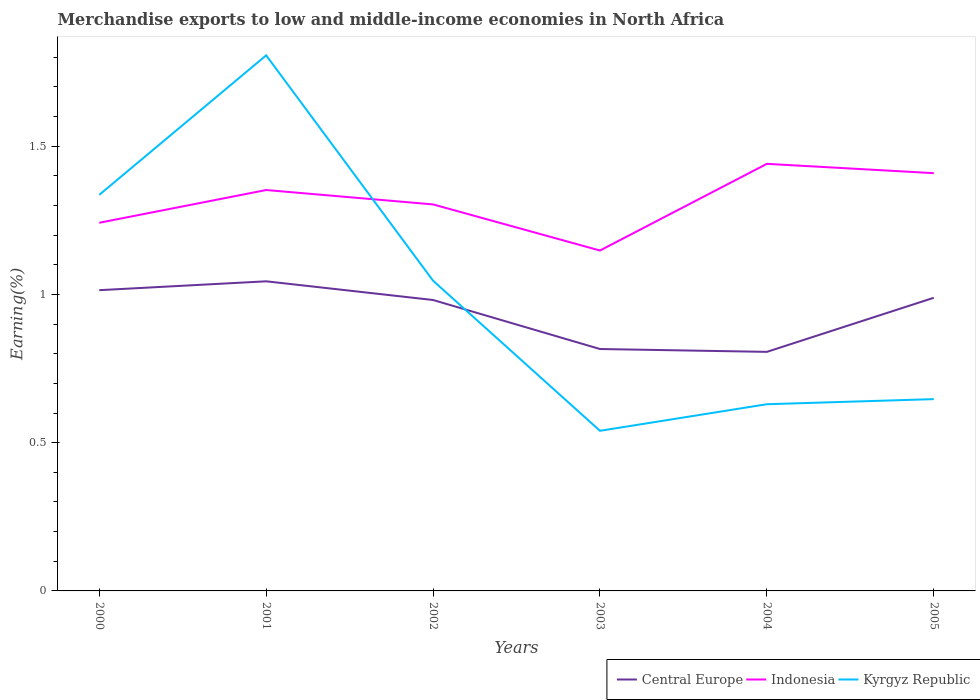How many different coloured lines are there?
Make the answer very short. 3. Does the line corresponding to Central Europe intersect with the line corresponding to Indonesia?
Your answer should be compact. No. Is the number of lines equal to the number of legend labels?
Provide a short and direct response. Yes. Across all years, what is the maximum percentage of amount earned from merchandise exports in Central Europe?
Give a very brief answer. 0.81. What is the total percentage of amount earned from merchandise exports in Indonesia in the graph?
Keep it short and to the point. -0.11. What is the difference between the highest and the second highest percentage of amount earned from merchandise exports in Indonesia?
Provide a short and direct response. 0.29. How many years are there in the graph?
Give a very brief answer. 6. What is the difference between two consecutive major ticks on the Y-axis?
Your answer should be very brief. 0.5. Are the values on the major ticks of Y-axis written in scientific E-notation?
Provide a succinct answer. No. Does the graph contain any zero values?
Provide a short and direct response. No. How many legend labels are there?
Your answer should be compact. 3. How are the legend labels stacked?
Give a very brief answer. Horizontal. What is the title of the graph?
Offer a terse response. Merchandise exports to low and middle-income economies in North Africa. What is the label or title of the Y-axis?
Offer a terse response. Earning(%). What is the Earning(%) of Central Europe in 2000?
Offer a very short reply. 1.01. What is the Earning(%) in Indonesia in 2000?
Ensure brevity in your answer.  1.24. What is the Earning(%) in Kyrgyz Republic in 2000?
Give a very brief answer. 1.34. What is the Earning(%) of Central Europe in 2001?
Offer a terse response. 1.04. What is the Earning(%) of Indonesia in 2001?
Give a very brief answer. 1.35. What is the Earning(%) of Kyrgyz Republic in 2001?
Your answer should be compact. 1.81. What is the Earning(%) in Central Europe in 2002?
Your response must be concise. 0.98. What is the Earning(%) of Indonesia in 2002?
Offer a terse response. 1.3. What is the Earning(%) of Kyrgyz Republic in 2002?
Provide a short and direct response. 1.05. What is the Earning(%) of Central Europe in 2003?
Keep it short and to the point. 0.82. What is the Earning(%) in Indonesia in 2003?
Your response must be concise. 1.15. What is the Earning(%) of Kyrgyz Republic in 2003?
Your answer should be very brief. 0.54. What is the Earning(%) of Central Europe in 2004?
Your answer should be very brief. 0.81. What is the Earning(%) in Indonesia in 2004?
Offer a terse response. 1.44. What is the Earning(%) in Kyrgyz Republic in 2004?
Offer a terse response. 0.63. What is the Earning(%) of Central Europe in 2005?
Provide a succinct answer. 0.99. What is the Earning(%) of Indonesia in 2005?
Give a very brief answer. 1.41. What is the Earning(%) of Kyrgyz Republic in 2005?
Offer a terse response. 0.65. Across all years, what is the maximum Earning(%) in Central Europe?
Provide a short and direct response. 1.04. Across all years, what is the maximum Earning(%) in Indonesia?
Make the answer very short. 1.44. Across all years, what is the maximum Earning(%) of Kyrgyz Republic?
Your answer should be very brief. 1.81. Across all years, what is the minimum Earning(%) of Central Europe?
Give a very brief answer. 0.81. Across all years, what is the minimum Earning(%) of Indonesia?
Offer a terse response. 1.15. Across all years, what is the minimum Earning(%) in Kyrgyz Republic?
Offer a terse response. 0.54. What is the total Earning(%) in Central Europe in the graph?
Offer a very short reply. 5.65. What is the total Earning(%) of Indonesia in the graph?
Keep it short and to the point. 7.9. What is the total Earning(%) in Kyrgyz Republic in the graph?
Provide a succinct answer. 6.01. What is the difference between the Earning(%) in Central Europe in 2000 and that in 2001?
Give a very brief answer. -0.03. What is the difference between the Earning(%) in Indonesia in 2000 and that in 2001?
Your answer should be very brief. -0.11. What is the difference between the Earning(%) in Kyrgyz Republic in 2000 and that in 2001?
Keep it short and to the point. -0.47. What is the difference between the Earning(%) of Central Europe in 2000 and that in 2002?
Ensure brevity in your answer.  0.03. What is the difference between the Earning(%) in Indonesia in 2000 and that in 2002?
Give a very brief answer. -0.06. What is the difference between the Earning(%) of Kyrgyz Republic in 2000 and that in 2002?
Make the answer very short. 0.29. What is the difference between the Earning(%) in Central Europe in 2000 and that in 2003?
Provide a succinct answer. 0.2. What is the difference between the Earning(%) of Indonesia in 2000 and that in 2003?
Provide a succinct answer. 0.09. What is the difference between the Earning(%) in Kyrgyz Republic in 2000 and that in 2003?
Provide a succinct answer. 0.8. What is the difference between the Earning(%) in Central Europe in 2000 and that in 2004?
Make the answer very short. 0.21. What is the difference between the Earning(%) in Indonesia in 2000 and that in 2004?
Your answer should be compact. -0.2. What is the difference between the Earning(%) of Kyrgyz Republic in 2000 and that in 2004?
Ensure brevity in your answer.  0.71. What is the difference between the Earning(%) in Central Europe in 2000 and that in 2005?
Offer a very short reply. 0.03. What is the difference between the Earning(%) in Indonesia in 2000 and that in 2005?
Give a very brief answer. -0.17. What is the difference between the Earning(%) of Kyrgyz Republic in 2000 and that in 2005?
Make the answer very short. 0.69. What is the difference between the Earning(%) of Central Europe in 2001 and that in 2002?
Your answer should be compact. 0.06. What is the difference between the Earning(%) of Indonesia in 2001 and that in 2002?
Keep it short and to the point. 0.05. What is the difference between the Earning(%) in Kyrgyz Republic in 2001 and that in 2002?
Your answer should be compact. 0.76. What is the difference between the Earning(%) of Central Europe in 2001 and that in 2003?
Provide a short and direct response. 0.23. What is the difference between the Earning(%) in Indonesia in 2001 and that in 2003?
Your answer should be very brief. 0.2. What is the difference between the Earning(%) in Kyrgyz Republic in 2001 and that in 2003?
Your answer should be very brief. 1.27. What is the difference between the Earning(%) in Central Europe in 2001 and that in 2004?
Make the answer very short. 0.24. What is the difference between the Earning(%) of Indonesia in 2001 and that in 2004?
Provide a short and direct response. -0.09. What is the difference between the Earning(%) of Kyrgyz Republic in 2001 and that in 2004?
Give a very brief answer. 1.18. What is the difference between the Earning(%) of Central Europe in 2001 and that in 2005?
Offer a very short reply. 0.06. What is the difference between the Earning(%) in Indonesia in 2001 and that in 2005?
Provide a short and direct response. -0.06. What is the difference between the Earning(%) in Kyrgyz Republic in 2001 and that in 2005?
Provide a succinct answer. 1.16. What is the difference between the Earning(%) of Central Europe in 2002 and that in 2003?
Offer a terse response. 0.17. What is the difference between the Earning(%) of Indonesia in 2002 and that in 2003?
Your answer should be very brief. 0.16. What is the difference between the Earning(%) in Kyrgyz Republic in 2002 and that in 2003?
Your answer should be compact. 0.51. What is the difference between the Earning(%) in Central Europe in 2002 and that in 2004?
Offer a terse response. 0.17. What is the difference between the Earning(%) of Indonesia in 2002 and that in 2004?
Your response must be concise. -0.14. What is the difference between the Earning(%) in Kyrgyz Republic in 2002 and that in 2004?
Provide a succinct answer. 0.42. What is the difference between the Earning(%) of Central Europe in 2002 and that in 2005?
Ensure brevity in your answer.  -0.01. What is the difference between the Earning(%) of Indonesia in 2002 and that in 2005?
Ensure brevity in your answer.  -0.11. What is the difference between the Earning(%) of Kyrgyz Republic in 2002 and that in 2005?
Offer a terse response. 0.4. What is the difference between the Earning(%) in Central Europe in 2003 and that in 2004?
Your answer should be compact. 0.01. What is the difference between the Earning(%) of Indonesia in 2003 and that in 2004?
Keep it short and to the point. -0.29. What is the difference between the Earning(%) in Kyrgyz Republic in 2003 and that in 2004?
Provide a short and direct response. -0.09. What is the difference between the Earning(%) of Central Europe in 2003 and that in 2005?
Offer a very short reply. -0.17. What is the difference between the Earning(%) in Indonesia in 2003 and that in 2005?
Make the answer very short. -0.26. What is the difference between the Earning(%) of Kyrgyz Republic in 2003 and that in 2005?
Offer a terse response. -0.11. What is the difference between the Earning(%) in Central Europe in 2004 and that in 2005?
Your response must be concise. -0.18. What is the difference between the Earning(%) in Indonesia in 2004 and that in 2005?
Make the answer very short. 0.03. What is the difference between the Earning(%) in Kyrgyz Republic in 2004 and that in 2005?
Offer a terse response. -0.02. What is the difference between the Earning(%) of Central Europe in 2000 and the Earning(%) of Indonesia in 2001?
Ensure brevity in your answer.  -0.34. What is the difference between the Earning(%) of Central Europe in 2000 and the Earning(%) of Kyrgyz Republic in 2001?
Offer a very short reply. -0.79. What is the difference between the Earning(%) in Indonesia in 2000 and the Earning(%) in Kyrgyz Republic in 2001?
Offer a terse response. -0.56. What is the difference between the Earning(%) of Central Europe in 2000 and the Earning(%) of Indonesia in 2002?
Give a very brief answer. -0.29. What is the difference between the Earning(%) in Central Europe in 2000 and the Earning(%) in Kyrgyz Republic in 2002?
Provide a succinct answer. -0.03. What is the difference between the Earning(%) of Indonesia in 2000 and the Earning(%) of Kyrgyz Republic in 2002?
Provide a short and direct response. 0.2. What is the difference between the Earning(%) in Central Europe in 2000 and the Earning(%) in Indonesia in 2003?
Give a very brief answer. -0.13. What is the difference between the Earning(%) in Central Europe in 2000 and the Earning(%) in Kyrgyz Republic in 2003?
Give a very brief answer. 0.47. What is the difference between the Earning(%) of Indonesia in 2000 and the Earning(%) of Kyrgyz Republic in 2003?
Your response must be concise. 0.7. What is the difference between the Earning(%) in Central Europe in 2000 and the Earning(%) in Indonesia in 2004?
Offer a terse response. -0.43. What is the difference between the Earning(%) of Central Europe in 2000 and the Earning(%) of Kyrgyz Republic in 2004?
Offer a terse response. 0.38. What is the difference between the Earning(%) in Indonesia in 2000 and the Earning(%) in Kyrgyz Republic in 2004?
Ensure brevity in your answer.  0.61. What is the difference between the Earning(%) in Central Europe in 2000 and the Earning(%) in Indonesia in 2005?
Provide a short and direct response. -0.39. What is the difference between the Earning(%) in Central Europe in 2000 and the Earning(%) in Kyrgyz Republic in 2005?
Your response must be concise. 0.37. What is the difference between the Earning(%) of Indonesia in 2000 and the Earning(%) of Kyrgyz Republic in 2005?
Your response must be concise. 0.59. What is the difference between the Earning(%) in Central Europe in 2001 and the Earning(%) in Indonesia in 2002?
Provide a succinct answer. -0.26. What is the difference between the Earning(%) of Central Europe in 2001 and the Earning(%) of Kyrgyz Republic in 2002?
Your answer should be very brief. -0. What is the difference between the Earning(%) in Indonesia in 2001 and the Earning(%) in Kyrgyz Republic in 2002?
Make the answer very short. 0.31. What is the difference between the Earning(%) of Central Europe in 2001 and the Earning(%) of Indonesia in 2003?
Your answer should be very brief. -0.1. What is the difference between the Earning(%) of Central Europe in 2001 and the Earning(%) of Kyrgyz Republic in 2003?
Keep it short and to the point. 0.5. What is the difference between the Earning(%) of Indonesia in 2001 and the Earning(%) of Kyrgyz Republic in 2003?
Your answer should be compact. 0.81. What is the difference between the Earning(%) of Central Europe in 2001 and the Earning(%) of Indonesia in 2004?
Offer a very short reply. -0.4. What is the difference between the Earning(%) in Central Europe in 2001 and the Earning(%) in Kyrgyz Republic in 2004?
Keep it short and to the point. 0.41. What is the difference between the Earning(%) of Indonesia in 2001 and the Earning(%) of Kyrgyz Republic in 2004?
Your response must be concise. 0.72. What is the difference between the Earning(%) in Central Europe in 2001 and the Earning(%) in Indonesia in 2005?
Make the answer very short. -0.36. What is the difference between the Earning(%) of Central Europe in 2001 and the Earning(%) of Kyrgyz Republic in 2005?
Provide a succinct answer. 0.4. What is the difference between the Earning(%) of Indonesia in 2001 and the Earning(%) of Kyrgyz Republic in 2005?
Ensure brevity in your answer.  0.71. What is the difference between the Earning(%) of Central Europe in 2002 and the Earning(%) of Indonesia in 2003?
Make the answer very short. -0.17. What is the difference between the Earning(%) in Central Europe in 2002 and the Earning(%) in Kyrgyz Republic in 2003?
Offer a terse response. 0.44. What is the difference between the Earning(%) of Indonesia in 2002 and the Earning(%) of Kyrgyz Republic in 2003?
Make the answer very short. 0.76. What is the difference between the Earning(%) in Central Europe in 2002 and the Earning(%) in Indonesia in 2004?
Your response must be concise. -0.46. What is the difference between the Earning(%) of Central Europe in 2002 and the Earning(%) of Kyrgyz Republic in 2004?
Provide a short and direct response. 0.35. What is the difference between the Earning(%) of Indonesia in 2002 and the Earning(%) of Kyrgyz Republic in 2004?
Make the answer very short. 0.67. What is the difference between the Earning(%) of Central Europe in 2002 and the Earning(%) of Indonesia in 2005?
Keep it short and to the point. -0.43. What is the difference between the Earning(%) in Central Europe in 2002 and the Earning(%) in Kyrgyz Republic in 2005?
Provide a short and direct response. 0.33. What is the difference between the Earning(%) of Indonesia in 2002 and the Earning(%) of Kyrgyz Republic in 2005?
Make the answer very short. 0.66. What is the difference between the Earning(%) in Central Europe in 2003 and the Earning(%) in Indonesia in 2004?
Offer a very short reply. -0.62. What is the difference between the Earning(%) in Central Europe in 2003 and the Earning(%) in Kyrgyz Republic in 2004?
Offer a terse response. 0.19. What is the difference between the Earning(%) of Indonesia in 2003 and the Earning(%) of Kyrgyz Republic in 2004?
Your response must be concise. 0.52. What is the difference between the Earning(%) in Central Europe in 2003 and the Earning(%) in Indonesia in 2005?
Offer a terse response. -0.59. What is the difference between the Earning(%) of Central Europe in 2003 and the Earning(%) of Kyrgyz Republic in 2005?
Offer a very short reply. 0.17. What is the difference between the Earning(%) in Indonesia in 2003 and the Earning(%) in Kyrgyz Republic in 2005?
Your answer should be very brief. 0.5. What is the difference between the Earning(%) in Central Europe in 2004 and the Earning(%) in Indonesia in 2005?
Make the answer very short. -0.6. What is the difference between the Earning(%) in Central Europe in 2004 and the Earning(%) in Kyrgyz Republic in 2005?
Provide a succinct answer. 0.16. What is the difference between the Earning(%) in Indonesia in 2004 and the Earning(%) in Kyrgyz Republic in 2005?
Offer a very short reply. 0.79. What is the average Earning(%) in Central Europe per year?
Offer a terse response. 0.94. What is the average Earning(%) in Indonesia per year?
Your response must be concise. 1.32. What is the average Earning(%) of Kyrgyz Republic per year?
Keep it short and to the point. 1. In the year 2000, what is the difference between the Earning(%) in Central Europe and Earning(%) in Indonesia?
Make the answer very short. -0.23. In the year 2000, what is the difference between the Earning(%) of Central Europe and Earning(%) of Kyrgyz Republic?
Keep it short and to the point. -0.32. In the year 2000, what is the difference between the Earning(%) of Indonesia and Earning(%) of Kyrgyz Republic?
Your response must be concise. -0.09. In the year 2001, what is the difference between the Earning(%) of Central Europe and Earning(%) of Indonesia?
Offer a terse response. -0.31. In the year 2001, what is the difference between the Earning(%) in Central Europe and Earning(%) in Kyrgyz Republic?
Provide a succinct answer. -0.76. In the year 2001, what is the difference between the Earning(%) of Indonesia and Earning(%) of Kyrgyz Republic?
Keep it short and to the point. -0.45. In the year 2002, what is the difference between the Earning(%) in Central Europe and Earning(%) in Indonesia?
Your answer should be compact. -0.32. In the year 2002, what is the difference between the Earning(%) in Central Europe and Earning(%) in Kyrgyz Republic?
Keep it short and to the point. -0.07. In the year 2002, what is the difference between the Earning(%) of Indonesia and Earning(%) of Kyrgyz Republic?
Ensure brevity in your answer.  0.26. In the year 2003, what is the difference between the Earning(%) in Central Europe and Earning(%) in Indonesia?
Offer a very short reply. -0.33. In the year 2003, what is the difference between the Earning(%) of Central Europe and Earning(%) of Kyrgyz Republic?
Your answer should be very brief. 0.28. In the year 2003, what is the difference between the Earning(%) of Indonesia and Earning(%) of Kyrgyz Republic?
Offer a terse response. 0.61. In the year 2004, what is the difference between the Earning(%) in Central Europe and Earning(%) in Indonesia?
Offer a terse response. -0.63. In the year 2004, what is the difference between the Earning(%) in Central Europe and Earning(%) in Kyrgyz Republic?
Provide a short and direct response. 0.18. In the year 2004, what is the difference between the Earning(%) of Indonesia and Earning(%) of Kyrgyz Republic?
Provide a short and direct response. 0.81. In the year 2005, what is the difference between the Earning(%) of Central Europe and Earning(%) of Indonesia?
Provide a succinct answer. -0.42. In the year 2005, what is the difference between the Earning(%) of Central Europe and Earning(%) of Kyrgyz Republic?
Give a very brief answer. 0.34. In the year 2005, what is the difference between the Earning(%) in Indonesia and Earning(%) in Kyrgyz Republic?
Your answer should be very brief. 0.76. What is the ratio of the Earning(%) of Central Europe in 2000 to that in 2001?
Your answer should be compact. 0.97. What is the ratio of the Earning(%) in Indonesia in 2000 to that in 2001?
Your answer should be very brief. 0.92. What is the ratio of the Earning(%) in Kyrgyz Republic in 2000 to that in 2001?
Your response must be concise. 0.74. What is the ratio of the Earning(%) of Central Europe in 2000 to that in 2002?
Your answer should be very brief. 1.03. What is the ratio of the Earning(%) in Indonesia in 2000 to that in 2002?
Provide a short and direct response. 0.95. What is the ratio of the Earning(%) in Kyrgyz Republic in 2000 to that in 2002?
Your answer should be very brief. 1.28. What is the ratio of the Earning(%) in Central Europe in 2000 to that in 2003?
Your answer should be compact. 1.24. What is the ratio of the Earning(%) in Indonesia in 2000 to that in 2003?
Give a very brief answer. 1.08. What is the ratio of the Earning(%) of Kyrgyz Republic in 2000 to that in 2003?
Your response must be concise. 2.47. What is the ratio of the Earning(%) of Central Europe in 2000 to that in 2004?
Your response must be concise. 1.26. What is the ratio of the Earning(%) of Indonesia in 2000 to that in 2004?
Give a very brief answer. 0.86. What is the ratio of the Earning(%) of Kyrgyz Republic in 2000 to that in 2004?
Make the answer very short. 2.12. What is the ratio of the Earning(%) in Central Europe in 2000 to that in 2005?
Offer a very short reply. 1.03. What is the ratio of the Earning(%) in Indonesia in 2000 to that in 2005?
Give a very brief answer. 0.88. What is the ratio of the Earning(%) of Kyrgyz Republic in 2000 to that in 2005?
Ensure brevity in your answer.  2.07. What is the ratio of the Earning(%) in Central Europe in 2001 to that in 2002?
Ensure brevity in your answer.  1.06. What is the ratio of the Earning(%) of Indonesia in 2001 to that in 2002?
Provide a succinct answer. 1.04. What is the ratio of the Earning(%) in Kyrgyz Republic in 2001 to that in 2002?
Give a very brief answer. 1.73. What is the ratio of the Earning(%) in Central Europe in 2001 to that in 2003?
Ensure brevity in your answer.  1.28. What is the ratio of the Earning(%) of Indonesia in 2001 to that in 2003?
Make the answer very short. 1.18. What is the ratio of the Earning(%) in Kyrgyz Republic in 2001 to that in 2003?
Keep it short and to the point. 3.34. What is the ratio of the Earning(%) in Central Europe in 2001 to that in 2004?
Provide a succinct answer. 1.3. What is the ratio of the Earning(%) of Indonesia in 2001 to that in 2004?
Offer a very short reply. 0.94. What is the ratio of the Earning(%) in Kyrgyz Republic in 2001 to that in 2004?
Your response must be concise. 2.87. What is the ratio of the Earning(%) of Central Europe in 2001 to that in 2005?
Offer a very short reply. 1.06. What is the ratio of the Earning(%) of Indonesia in 2001 to that in 2005?
Offer a very short reply. 0.96. What is the ratio of the Earning(%) in Kyrgyz Republic in 2001 to that in 2005?
Ensure brevity in your answer.  2.79. What is the ratio of the Earning(%) of Central Europe in 2002 to that in 2003?
Your answer should be very brief. 1.2. What is the ratio of the Earning(%) in Indonesia in 2002 to that in 2003?
Make the answer very short. 1.14. What is the ratio of the Earning(%) of Kyrgyz Republic in 2002 to that in 2003?
Your answer should be compact. 1.94. What is the ratio of the Earning(%) of Central Europe in 2002 to that in 2004?
Give a very brief answer. 1.22. What is the ratio of the Earning(%) of Indonesia in 2002 to that in 2004?
Ensure brevity in your answer.  0.91. What is the ratio of the Earning(%) of Kyrgyz Republic in 2002 to that in 2004?
Provide a short and direct response. 1.66. What is the ratio of the Earning(%) of Central Europe in 2002 to that in 2005?
Offer a terse response. 0.99. What is the ratio of the Earning(%) in Indonesia in 2002 to that in 2005?
Offer a very short reply. 0.93. What is the ratio of the Earning(%) in Kyrgyz Republic in 2002 to that in 2005?
Provide a succinct answer. 1.62. What is the ratio of the Earning(%) in Central Europe in 2003 to that in 2004?
Provide a succinct answer. 1.01. What is the ratio of the Earning(%) in Indonesia in 2003 to that in 2004?
Keep it short and to the point. 0.8. What is the ratio of the Earning(%) of Kyrgyz Republic in 2003 to that in 2004?
Provide a short and direct response. 0.86. What is the ratio of the Earning(%) of Central Europe in 2003 to that in 2005?
Ensure brevity in your answer.  0.83. What is the ratio of the Earning(%) of Indonesia in 2003 to that in 2005?
Provide a short and direct response. 0.81. What is the ratio of the Earning(%) in Kyrgyz Republic in 2003 to that in 2005?
Your answer should be compact. 0.83. What is the ratio of the Earning(%) in Central Europe in 2004 to that in 2005?
Ensure brevity in your answer.  0.82. What is the ratio of the Earning(%) in Indonesia in 2004 to that in 2005?
Your response must be concise. 1.02. What is the ratio of the Earning(%) in Kyrgyz Republic in 2004 to that in 2005?
Provide a short and direct response. 0.97. What is the difference between the highest and the second highest Earning(%) of Central Europe?
Give a very brief answer. 0.03. What is the difference between the highest and the second highest Earning(%) of Indonesia?
Your answer should be compact. 0.03. What is the difference between the highest and the second highest Earning(%) of Kyrgyz Republic?
Provide a short and direct response. 0.47. What is the difference between the highest and the lowest Earning(%) of Central Europe?
Your answer should be very brief. 0.24. What is the difference between the highest and the lowest Earning(%) of Indonesia?
Make the answer very short. 0.29. What is the difference between the highest and the lowest Earning(%) of Kyrgyz Republic?
Provide a short and direct response. 1.27. 